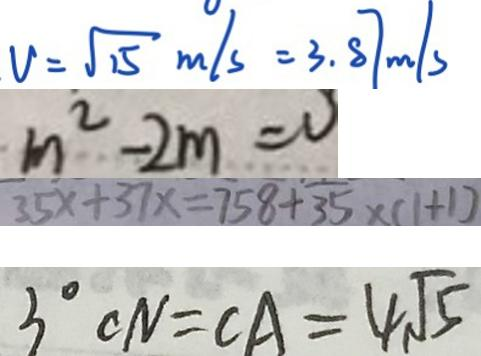<formula> <loc_0><loc_0><loc_500><loc_500>V = \sqrt { 1 5 } m / s = 3 . 8 7 m / s 
 m ^ { 2 } - 2 m = 0 
 3 5 x + 3 7 x = 7 5 8 + 3 5 \times ( 1 + 1 ) 
 3 ^ { \circ } C N = C A = 4 \sqrt { 5 }</formula> 